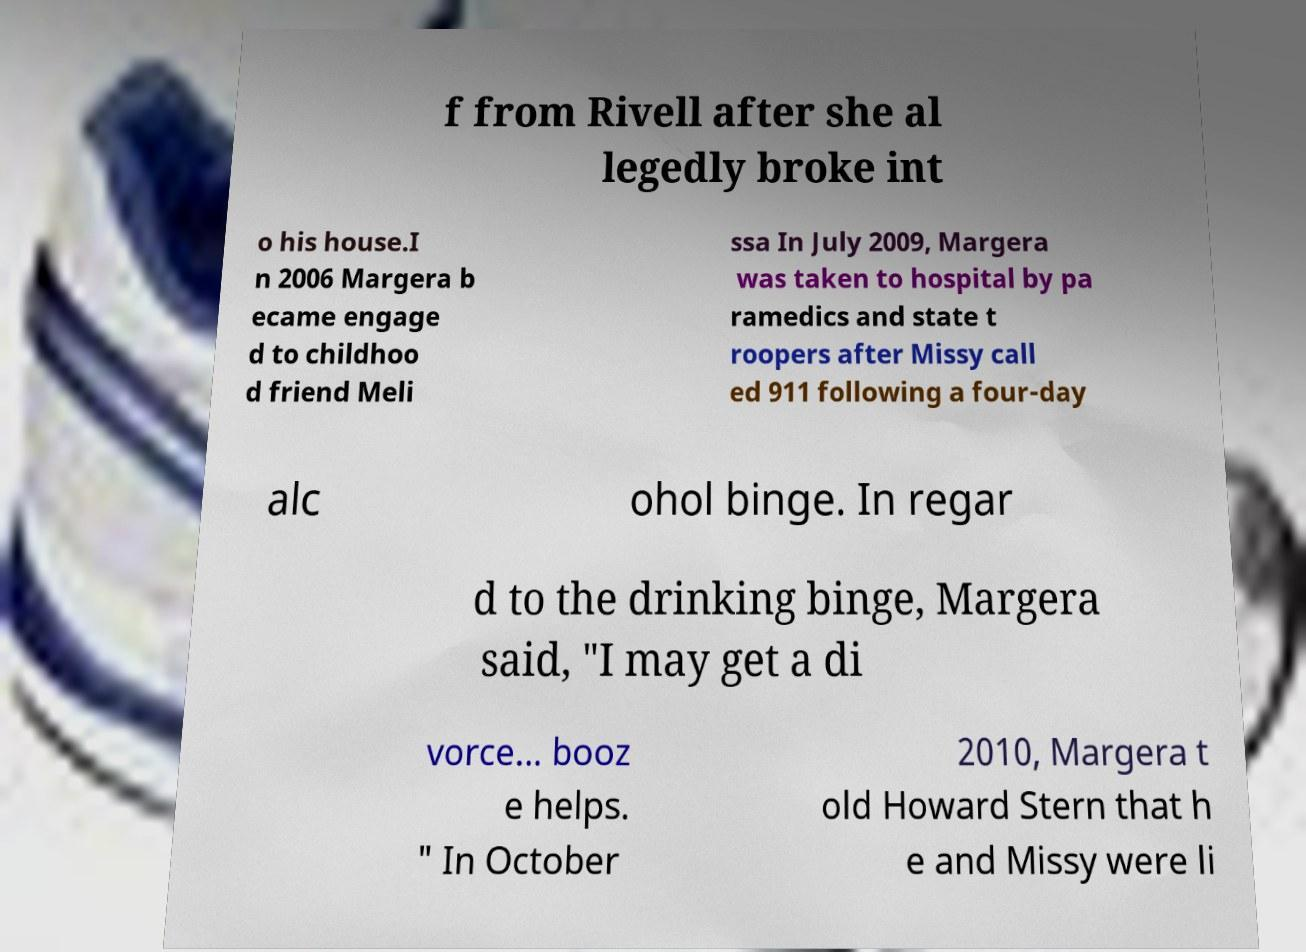Please identify and transcribe the text found in this image. f from Rivell after she al legedly broke int o his house.I n 2006 Margera b ecame engage d to childhoo d friend Meli ssa In July 2009, Margera was taken to hospital by pa ramedics and state t roopers after Missy call ed 911 following a four-day alc ohol binge. In regar d to the drinking binge, Margera said, "I may get a di vorce... booz e helps. " In October 2010, Margera t old Howard Stern that h e and Missy were li 